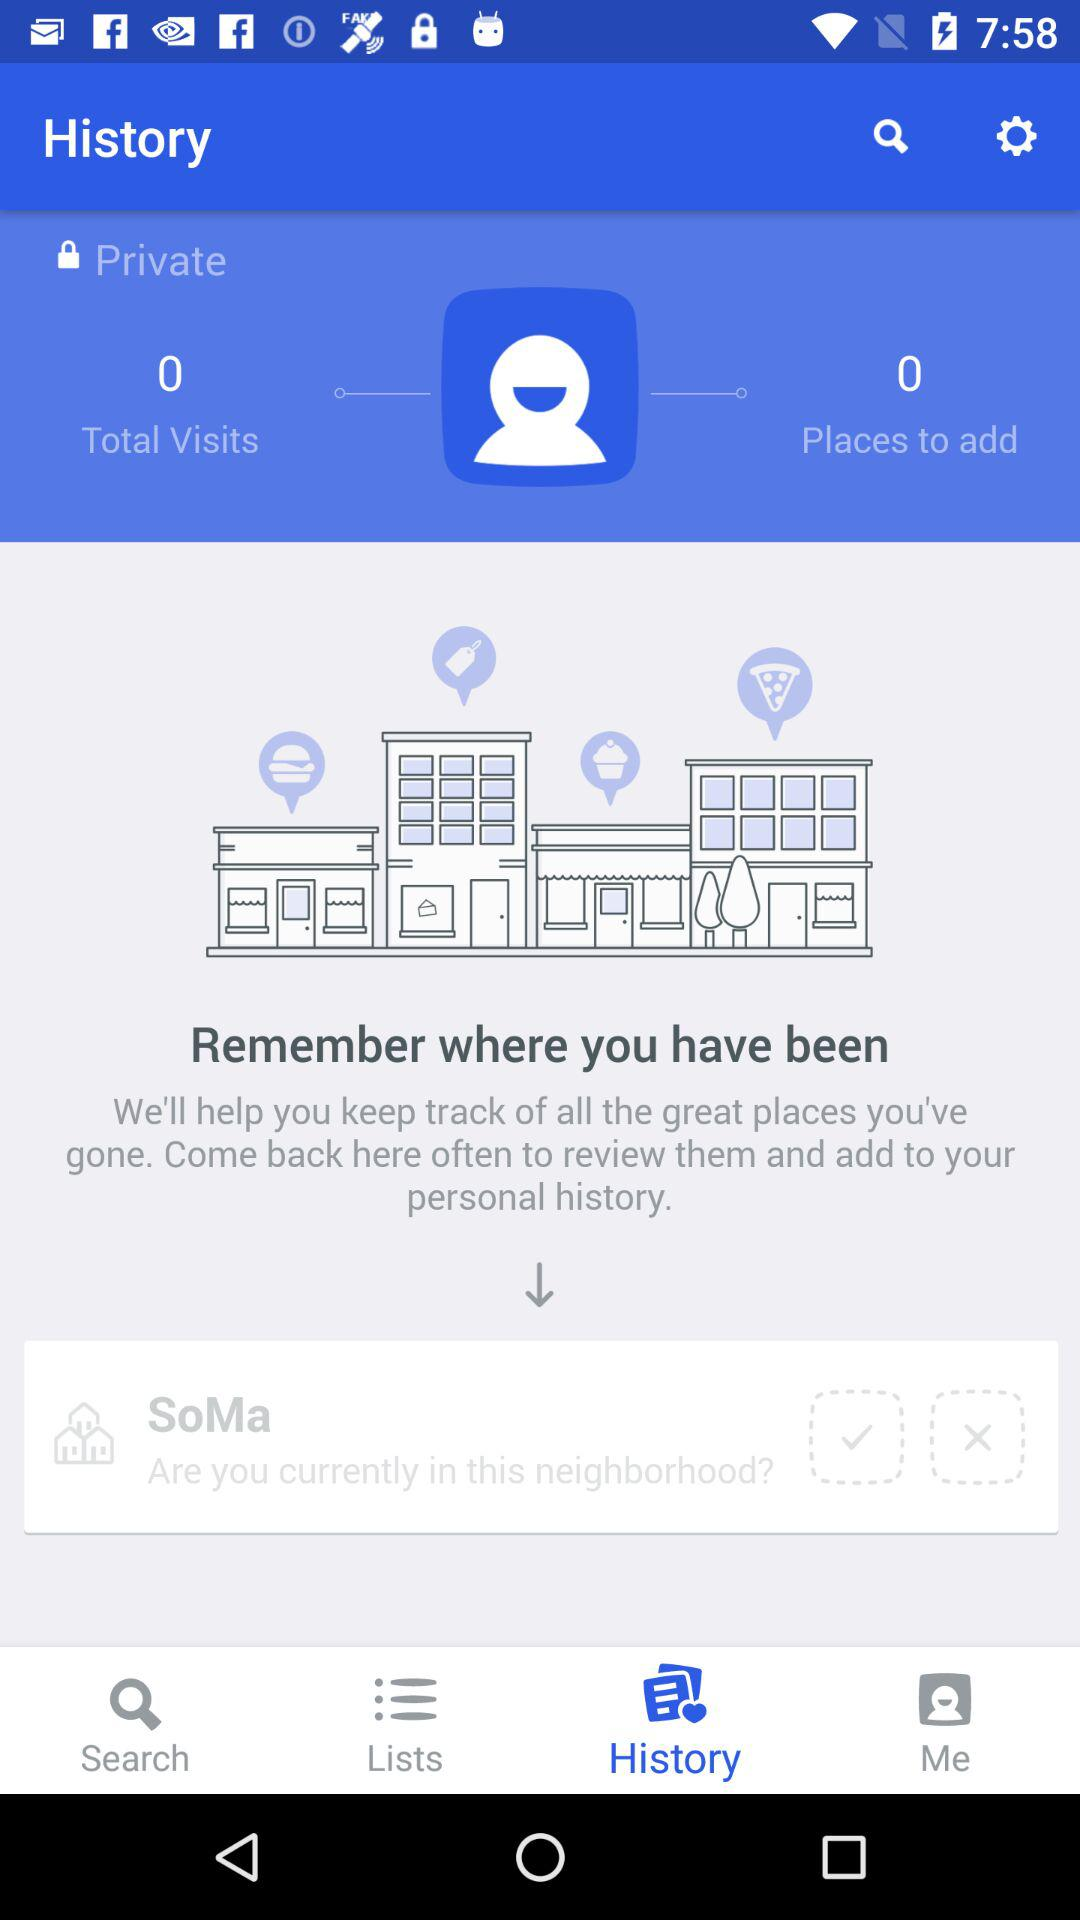How many visits in total are there? There are 0 visits. 